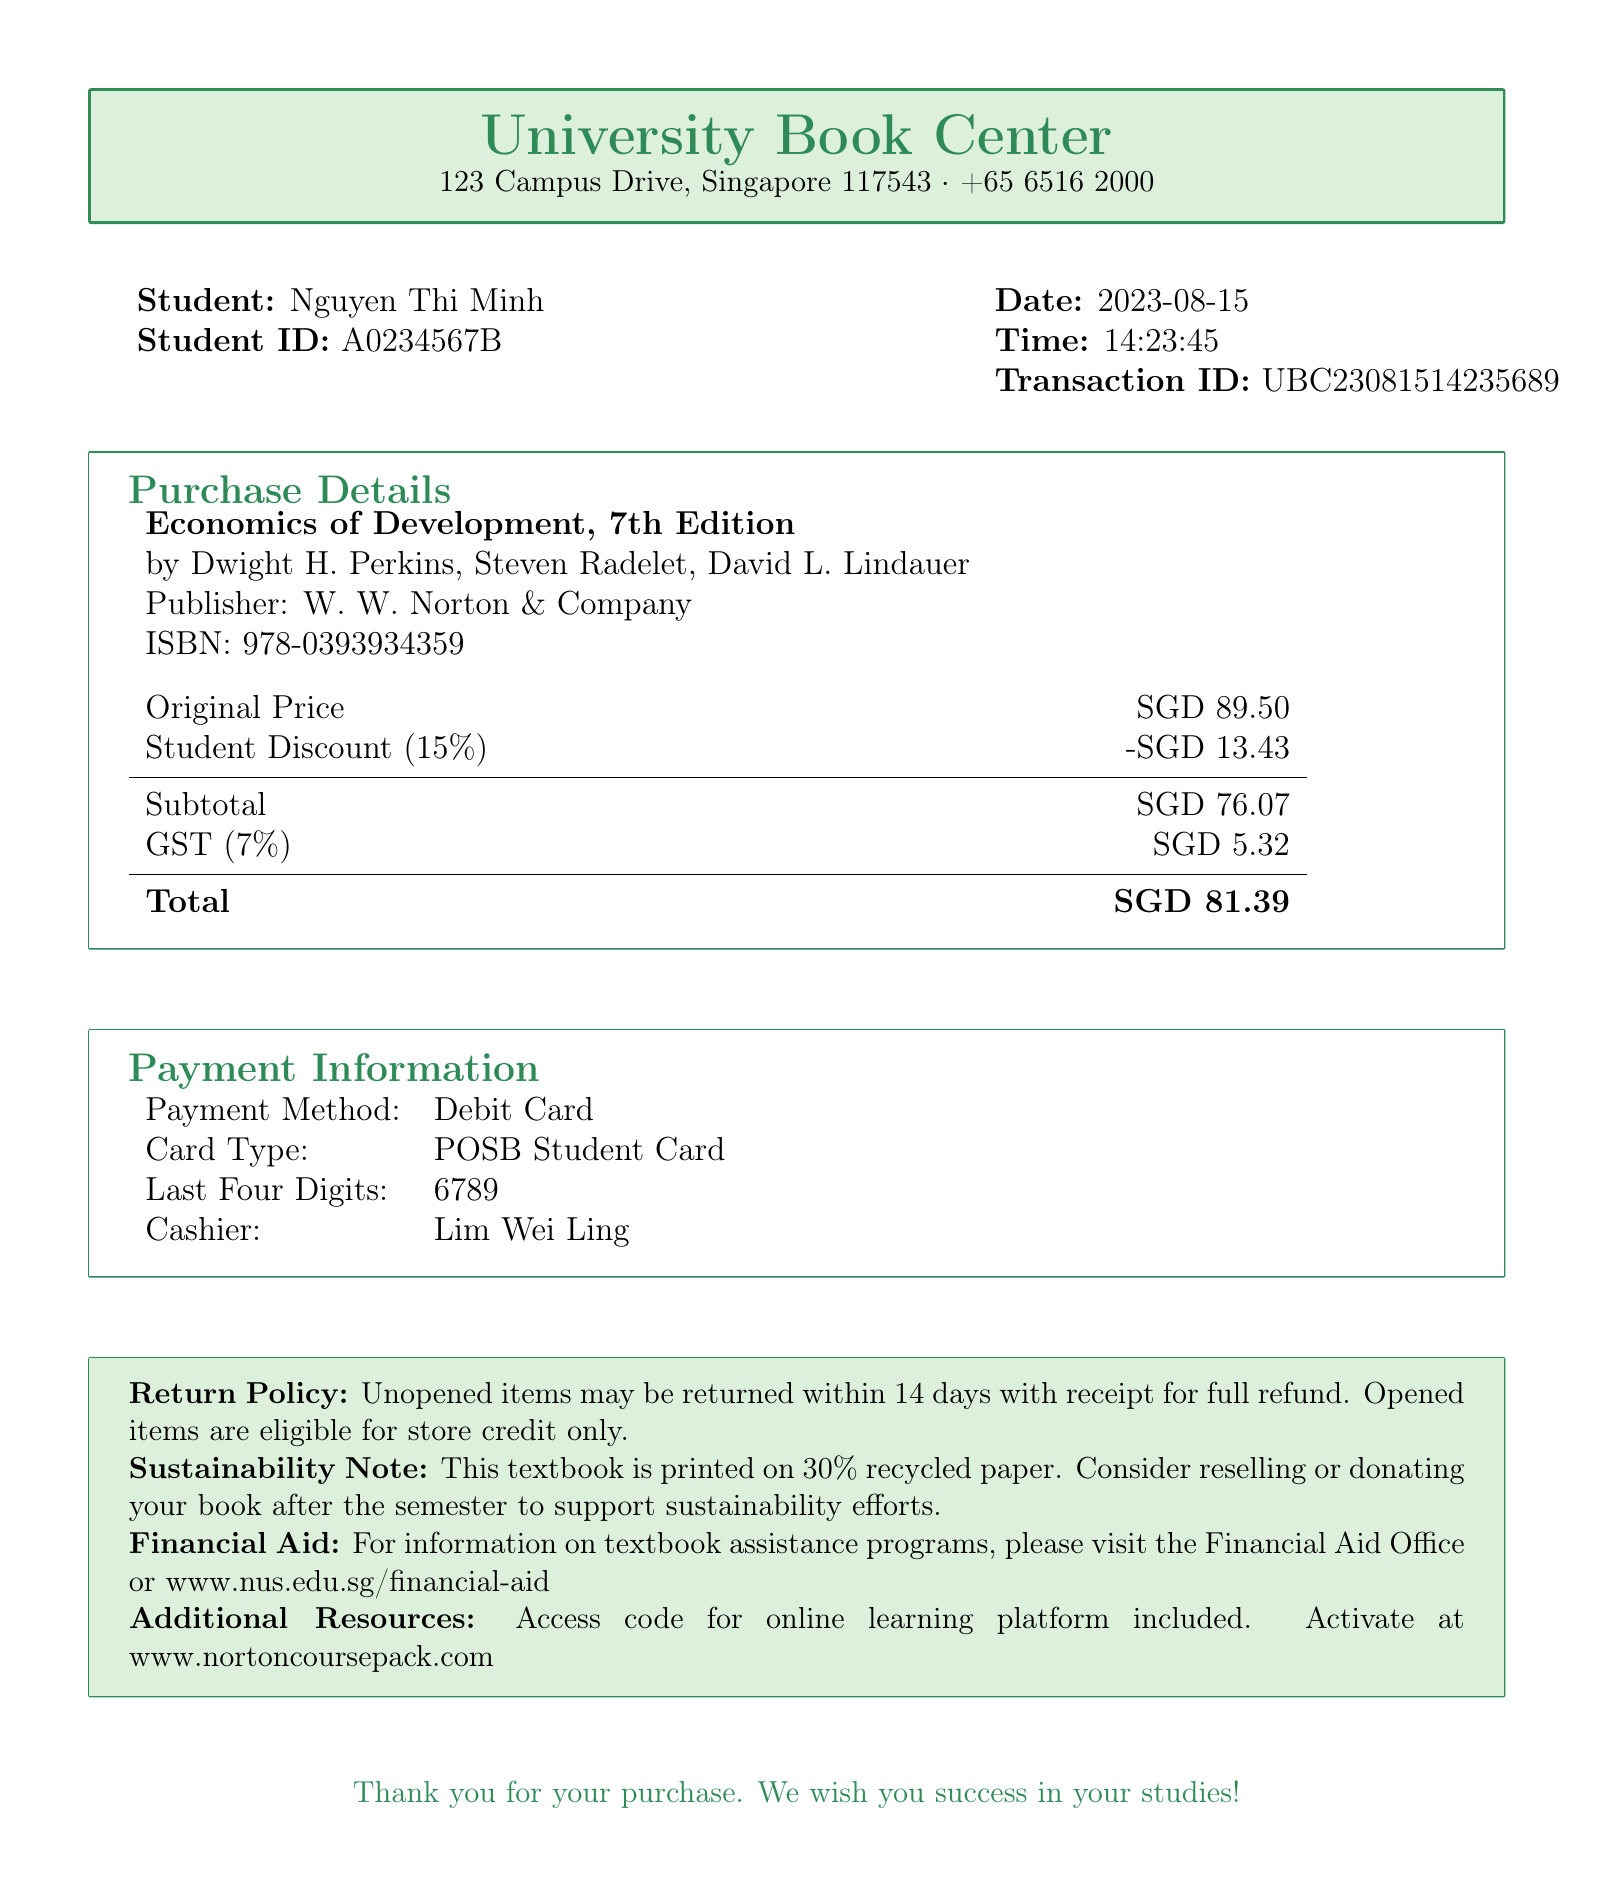What is the store name? The store name is stated at the top of the document, identifying where the purchase was made.
Answer: University Book Center What is the transaction date? The transaction date is provided to signify when the purchase occurred.
Answer: 2023-08-15 What is the original price of the textbook? The original price is listed in the purchase details section.
Answer: SGD 89.50 What percentage is the student discount? The student discount percentage is explicitly mentioned in the document.
Answer: 15% What is the total amount paid? The total amount is calculated as the sum of the subtotal and GST, provided at the end of the purchase details.
Answer: SGD 81.39 Who was the cashier during this transaction? The cashier's name is specified next to the payment information in the document.
Answer: Lim Wei Ling What is the GST percentage? The GST percentage is noted in the document to indicate the applicable tax on the purchase.
Answer: 7% What is the return policy for unopened items? The information regarding unopened items in the return policy is clearly mentioned in the document.
Answer: Unopened items may be returned within 14 days with receipt for full refund What should students do with the textbook after the semester? The sustainability note provides guidance on what to do with the book after use.
Answer: Consider reselling or donating your book after the semester to support sustainability efforts 